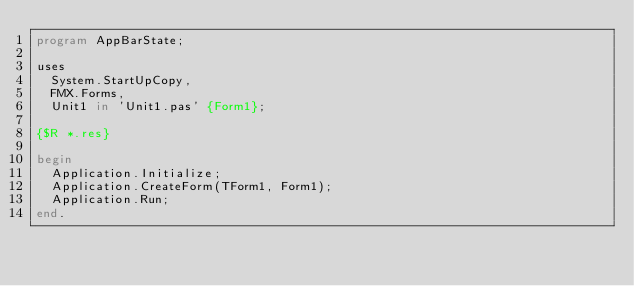Convert code to text. <code><loc_0><loc_0><loc_500><loc_500><_Pascal_>program AppBarState;

uses
  System.StartUpCopy,
  FMX.Forms,
  Unit1 in 'Unit1.pas' {Form1};

{$R *.res}

begin
  Application.Initialize;
  Application.CreateForm(TForm1, Form1);
  Application.Run;
end.
</code> 